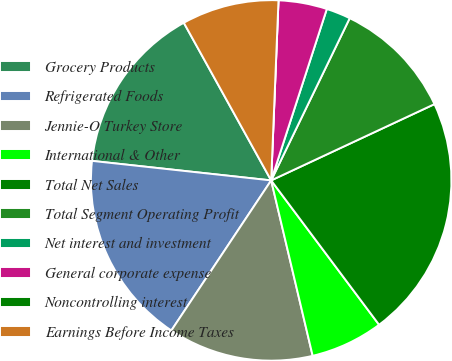<chart> <loc_0><loc_0><loc_500><loc_500><pie_chart><fcel>Grocery Products<fcel>Refrigerated Foods<fcel>Jennie-O Turkey Store<fcel>International & Other<fcel>Total Net Sales<fcel>Total Segment Operating Profit<fcel>Net interest and investment<fcel>General corporate expense<fcel>Noncontrolling interest<fcel>Earnings Before Income Taxes<nl><fcel>15.22%<fcel>17.39%<fcel>13.04%<fcel>6.52%<fcel>21.74%<fcel>10.87%<fcel>2.18%<fcel>4.35%<fcel>0.0%<fcel>8.7%<nl></chart> 